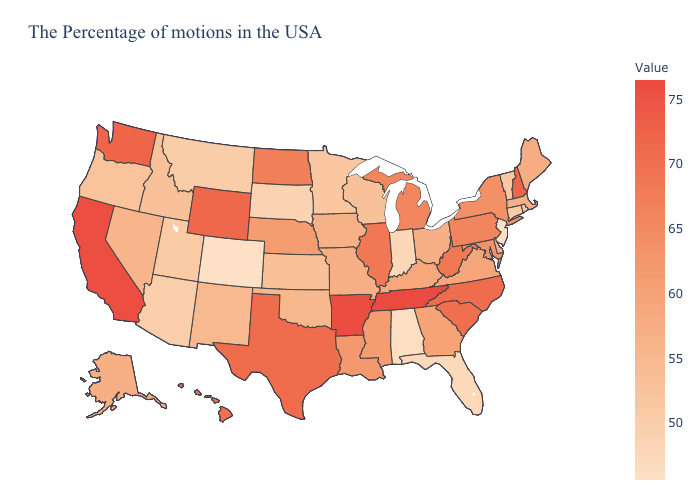Does Wisconsin have the lowest value in the MidWest?
Give a very brief answer. No. Does Tennessee have the lowest value in the South?
Quick response, please. No. Which states have the lowest value in the West?
Concise answer only. Colorado. Does Minnesota have the lowest value in the USA?
Give a very brief answer. No. Among the states that border California , does Arizona have the lowest value?
Be succinct. Yes. Which states have the highest value in the USA?
Answer briefly. Tennessee. 